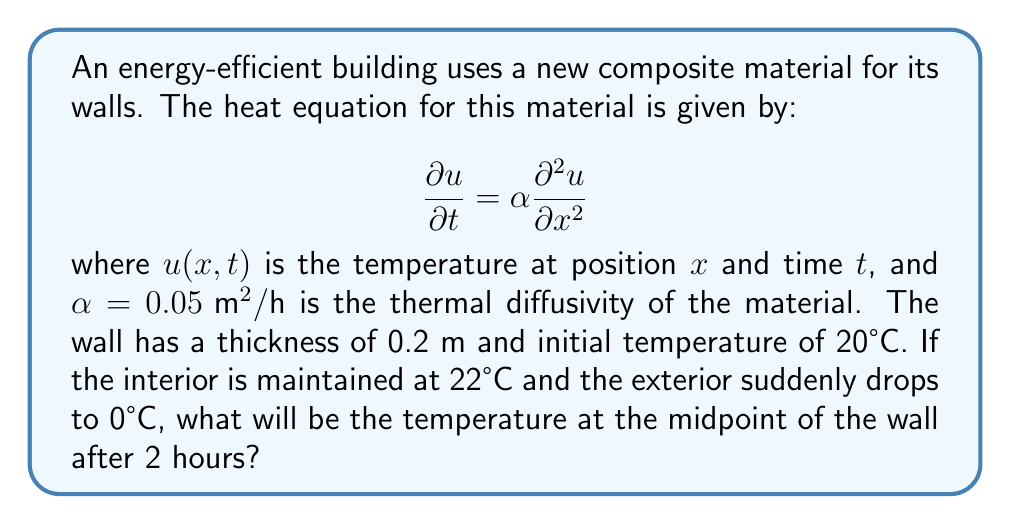Can you solve this math problem? To solve this problem, we'll use the solution to the one-dimensional heat equation with constant boundary conditions:

1) The general solution is given by:

   $$u(x,t) = A + Bx + \sum_{n=1}^{\infty} C_n e^{-\alpha n^2 \pi^2 t / L^2} \sin(n\pi x/L)$$

2) Here, $L = 0.2 \text{ m}$ (wall thickness), $\alpha = 0.05 \text{ m}^2/\text{h}$, and we're interested in $t = 2 \text{ h}$.

3) The boundary conditions are:
   $u(0,t) = 22°C$ (interior)
   $u(L,t) = 0°C$ (exterior)

4) This gives us $A = 22$ and $B = -110$.

5) The initial condition $u(x,0) = 20°C$ leads to:

   $$20 = 22 - 110x + \sum_{n=1}^{\infty} C_n \sin(n\pi x/0.2)$$

6) Solving for $C_n$:

   $$C_n = \frac{2}{L} \int_0^L [20 - (22 - 110x)] \sin(n\pi x/L) dx = \frac{440}{n\pi} (1 - (-1)^n)$$

7) The temperature at the midpoint $(x = 0.1 \text{ m})$ after 2 hours is:

   $$u(0.1, 2) = 22 - 110(0.1) + \sum_{n=1}^{\infty} \frac{440}{n\pi} (1 - (-1)^n) e^{-0.05 n^2 \pi^2 2 / 0.2^2} \sin(n\pi 0.1/0.2)$$

8) Evaluating this sum (taking the first few terms for approximation):

   $$u(0.1, 2) \approx 11 + 280 \cdot 0.0019 - 93 \cdot 0.0000035 + 56 \cdot 0.0000000007 \approx 11.53°C$$
Answer: 11.53°C 